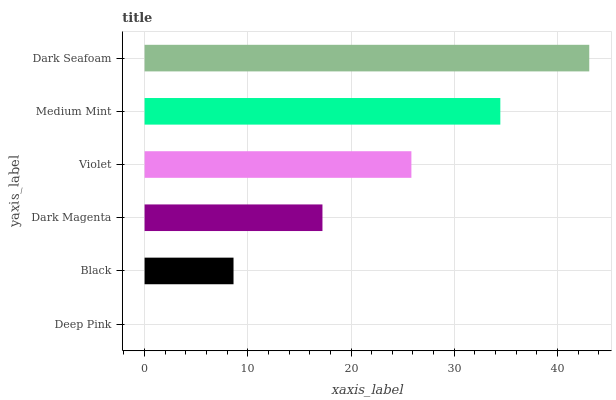Is Deep Pink the minimum?
Answer yes or no. Yes. Is Dark Seafoam the maximum?
Answer yes or no. Yes. Is Black the minimum?
Answer yes or no. No. Is Black the maximum?
Answer yes or no. No. Is Black greater than Deep Pink?
Answer yes or no. Yes. Is Deep Pink less than Black?
Answer yes or no. Yes. Is Deep Pink greater than Black?
Answer yes or no. No. Is Black less than Deep Pink?
Answer yes or no. No. Is Violet the high median?
Answer yes or no. Yes. Is Dark Magenta the low median?
Answer yes or no. Yes. Is Medium Mint the high median?
Answer yes or no. No. Is Black the low median?
Answer yes or no. No. 